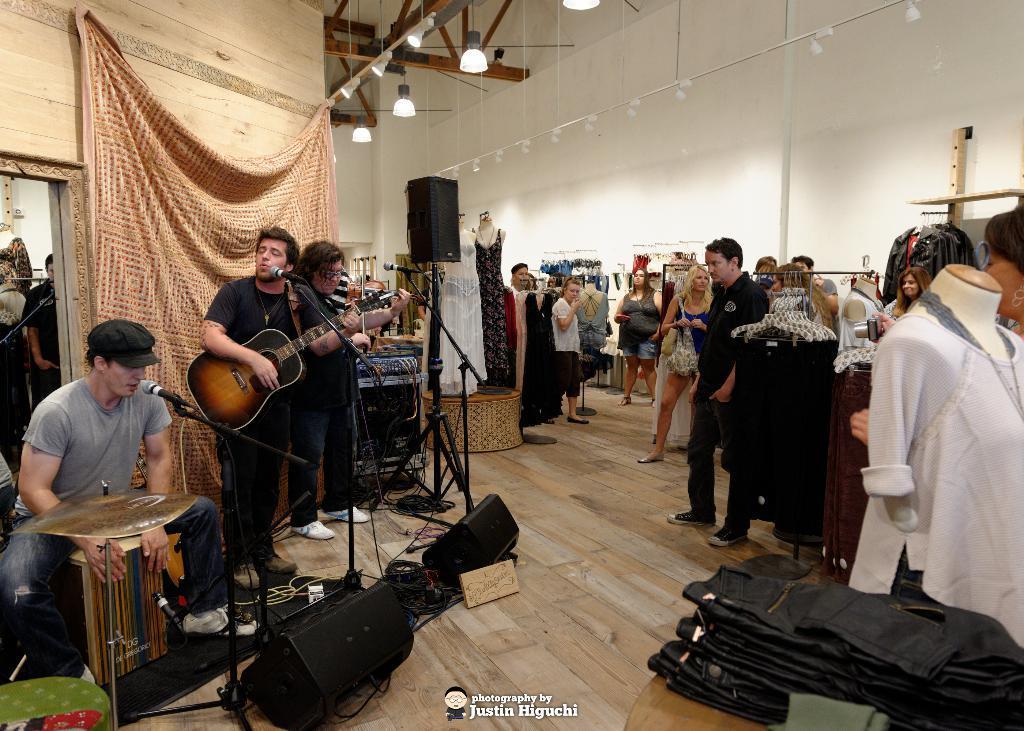How would you summarize this image in a sentence or two? In this image There are few people in the store in which one of them is playing the guitar while there is a mic in front of him and beside him there is another man who is playing the drums. At the top there is light. To the right side there is a wall and people in front of the wall. At the bottom there are clothes. 